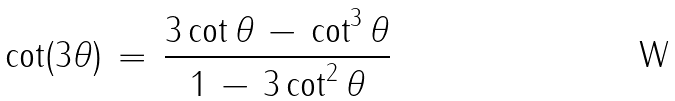<formula> <loc_0><loc_0><loc_500><loc_500>\cot ( 3 \theta ) \, = \, { \frac { 3 \cot \theta \, - \, \cot ^ { 3 } \theta } { 1 \, - \, 3 \cot ^ { 2 } \theta } }</formula> 